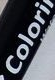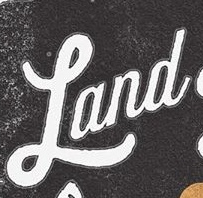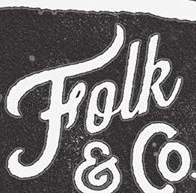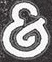Read the text from these images in sequence, separated by a semicolon. Colori; Land; Folk; & 